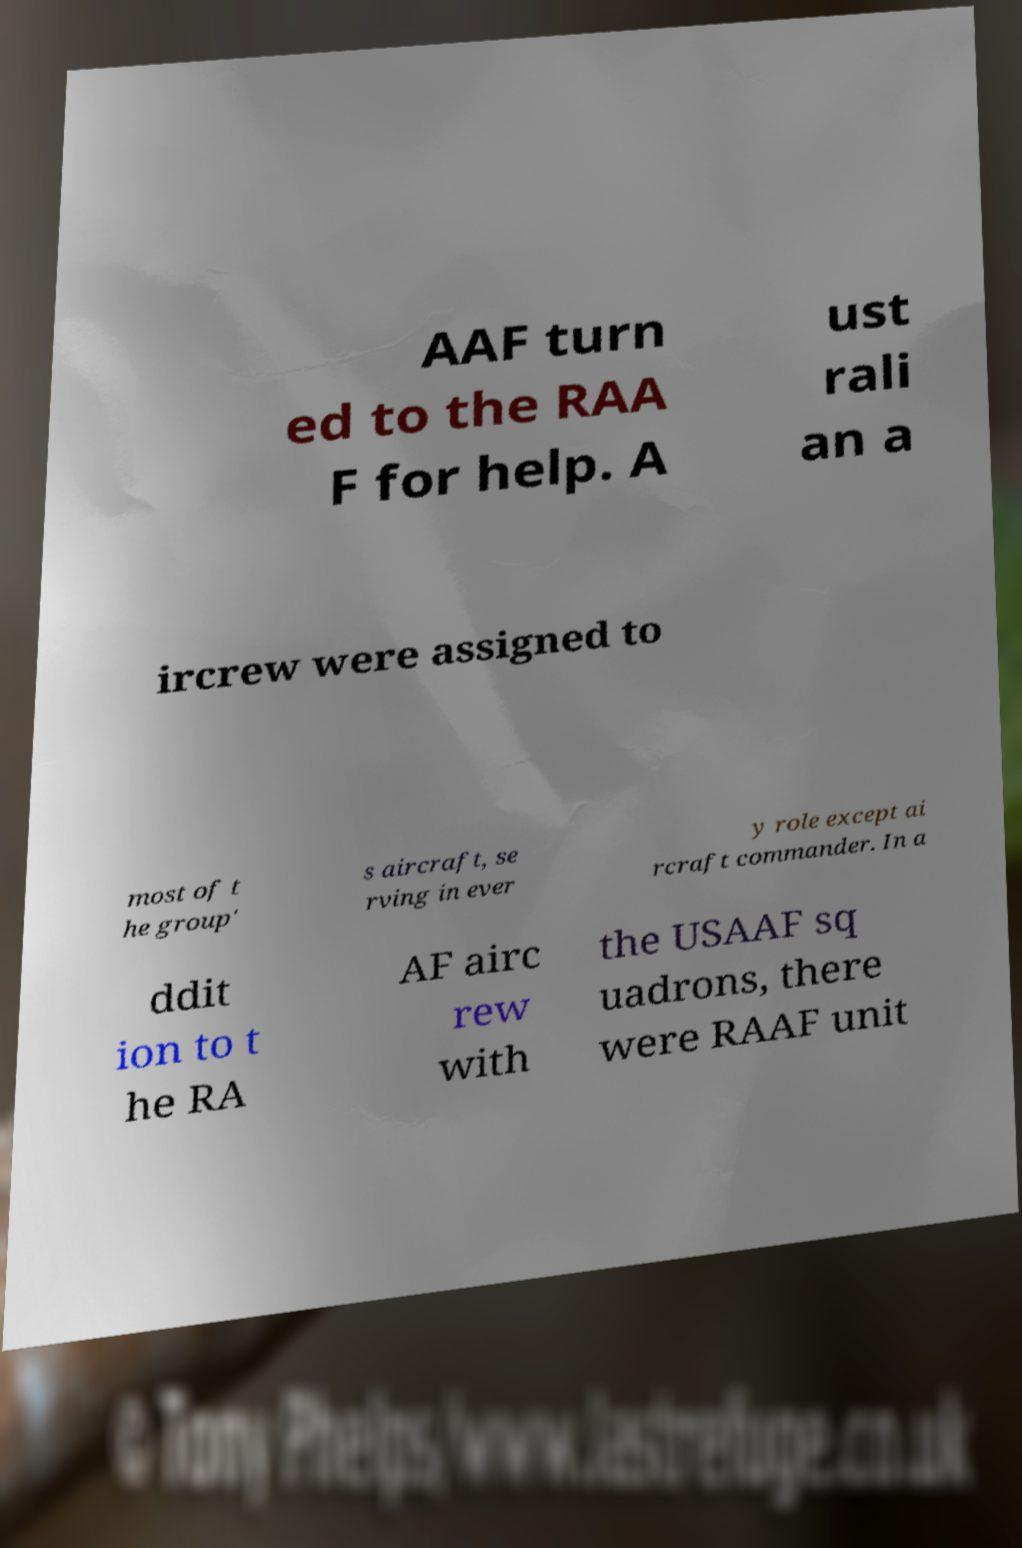For documentation purposes, I need the text within this image transcribed. Could you provide that? AAF turn ed to the RAA F for help. A ust rali an a ircrew were assigned to most of t he group' s aircraft, se rving in ever y role except ai rcraft commander. In a ddit ion to t he RA AF airc rew with the USAAF sq uadrons, there were RAAF unit 